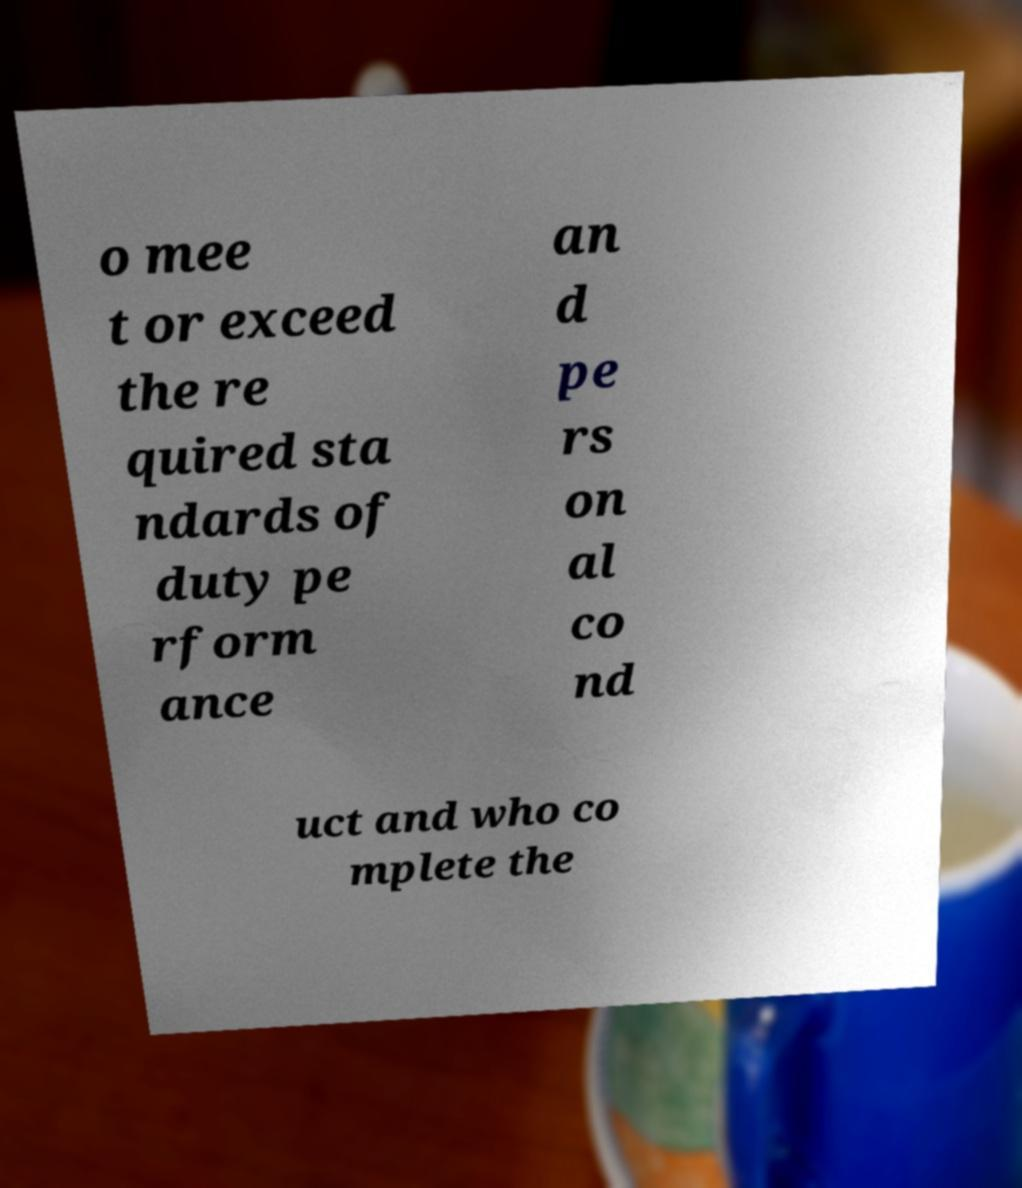There's text embedded in this image that I need extracted. Can you transcribe it verbatim? o mee t or exceed the re quired sta ndards of duty pe rform ance an d pe rs on al co nd uct and who co mplete the 